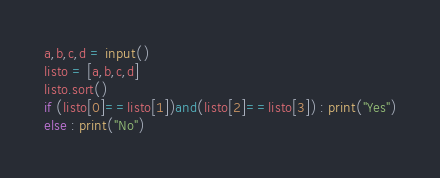Convert code to text. <code><loc_0><loc_0><loc_500><loc_500><_Python_>a,b,c,d = input()
listo = [a,b,c,d]
listo.sort()
if (listo[0]==listo[1])and(listo[2]==listo[3]) : print("Yes")
else : print("No")</code> 